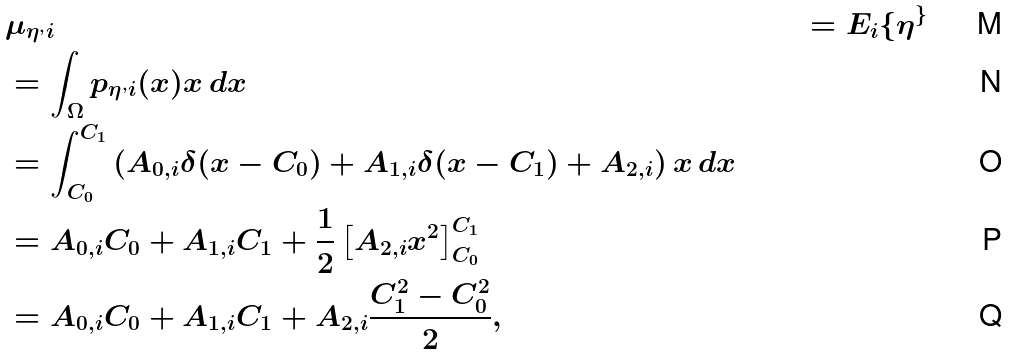<formula> <loc_0><loc_0><loc_500><loc_500>& \mu _ { \eta ^ { , } i } & = E _ { i } \{ \eta ^ { \} } \\ & = \int _ { \Omega } p _ { \eta ^ { , } i } ( x ) x \, d x \\ & = \int _ { C _ { 0 } } ^ { C _ { 1 } } \left ( A _ { 0 , i } \delta ( x - C _ { 0 } ) + A _ { 1 , i } \delta ( x - C _ { 1 } ) + A _ { 2 , i } \right ) x \, d x \\ & = A _ { 0 , i } C _ { 0 } + A _ { 1 , i } C _ { 1 } + \frac { 1 } { 2 } \left [ A _ { 2 , i } x ^ { 2 } \right ] _ { C _ { 0 } } ^ { C _ { 1 } } \\ & = A _ { 0 , i } C _ { 0 } + A _ { 1 , i } C _ { 1 } + A _ { 2 , i } \frac { C _ { 1 } ^ { 2 } - C _ { 0 } ^ { 2 } } { 2 } ,</formula> 